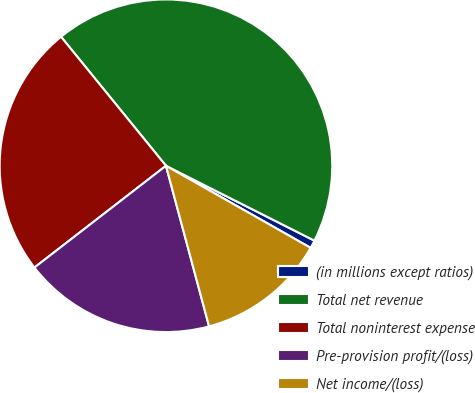Convert chart. <chart><loc_0><loc_0><loc_500><loc_500><pie_chart><fcel>(in millions except ratios)<fcel>Total net revenue<fcel>Total noninterest expense<fcel>Pre-provision profit/(loss)<fcel>Net income/(loss)<nl><fcel>0.78%<fcel>43.3%<fcel>24.61%<fcel>18.69%<fcel>12.61%<nl></chart> 